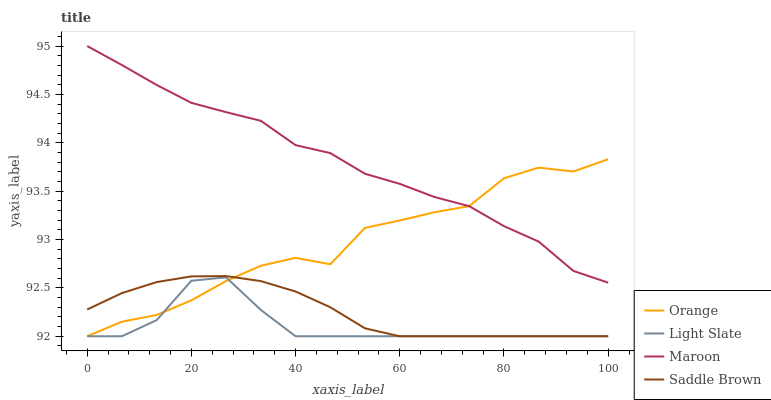Does Light Slate have the minimum area under the curve?
Answer yes or no. Yes. Does Maroon have the maximum area under the curve?
Answer yes or no. Yes. Does Saddle Brown have the minimum area under the curve?
Answer yes or no. No. Does Saddle Brown have the maximum area under the curve?
Answer yes or no. No. Is Saddle Brown the smoothest?
Answer yes or no. Yes. Is Orange the roughest?
Answer yes or no. Yes. Is Light Slate the smoothest?
Answer yes or no. No. Is Light Slate the roughest?
Answer yes or no. No. Does Orange have the lowest value?
Answer yes or no. Yes. Does Maroon have the lowest value?
Answer yes or no. No. Does Maroon have the highest value?
Answer yes or no. Yes. Does Saddle Brown have the highest value?
Answer yes or no. No. Is Light Slate less than Maroon?
Answer yes or no. Yes. Is Maroon greater than Saddle Brown?
Answer yes or no. Yes. Does Light Slate intersect Saddle Brown?
Answer yes or no. Yes. Is Light Slate less than Saddle Brown?
Answer yes or no. No. Is Light Slate greater than Saddle Brown?
Answer yes or no. No. Does Light Slate intersect Maroon?
Answer yes or no. No. 